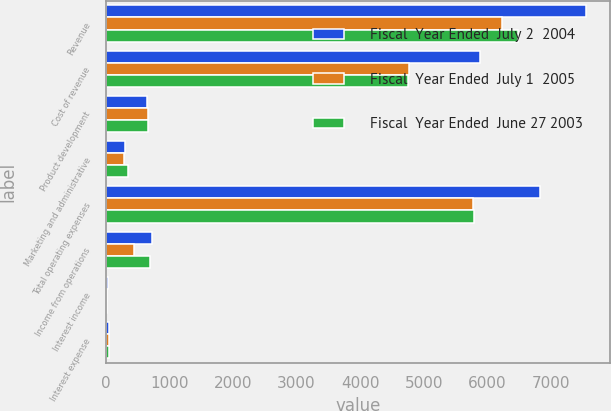Convert chart to OTSL. <chart><loc_0><loc_0><loc_500><loc_500><stacked_bar_chart><ecel><fcel>Revenue<fcel>Cost of revenue<fcel>Product development<fcel>Marketing and administrative<fcel>Total operating expenses<fcel>Income from operations<fcel>Interest income<fcel>Interest expense<nl><fcel>Fiscal  Year Ended  July 2  2004<fcel>7553<fcel>5880<fcel>645<fcel>306<fcel>6831<fcel>722<fcel>36<fcel>48<nl><fcel>Fiscal  Year Ended  July 1  2005<fcel>6224<fcel>4765<fcel>666<fcel>290<fcel>5780<fcel>444<fcel>17<fcel>45<nl><fcel>Fiscal  Year Ended  June 27 2003<fcel>6486<fcel>4759<fcel>670<fcel>357<fcel>5795<fcel>691<fcel>16<fcel>47<nl></chart> 